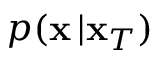<formula> <loc_0><loc_0><loc_500><loc_500>p ( x \, | x _ { T } )</formula> 